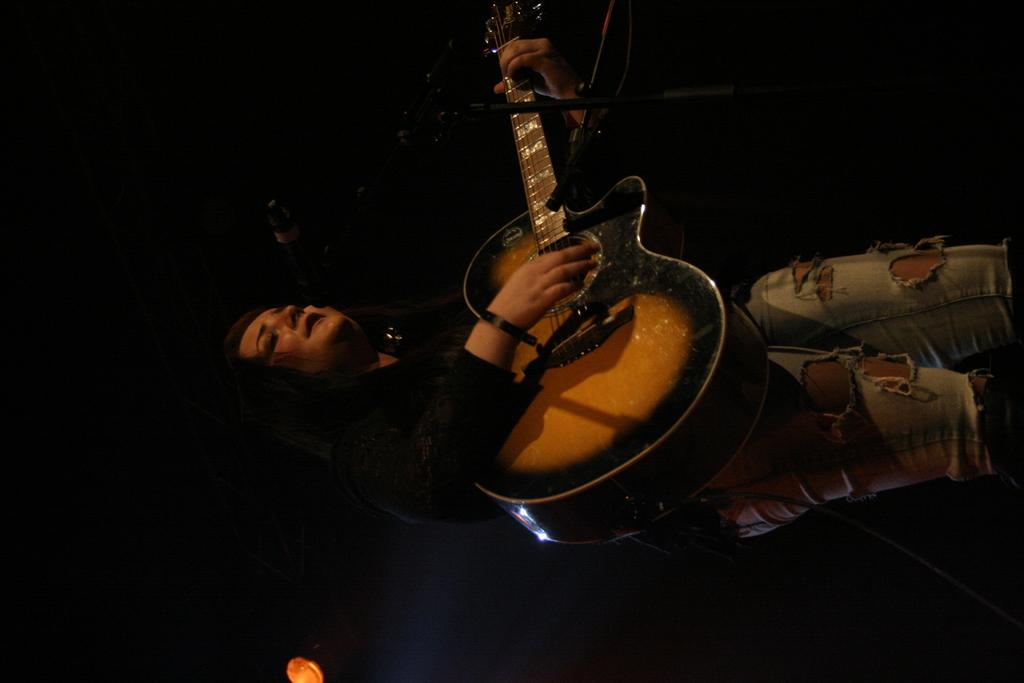Who is the main subject in the image? There is a woman in the image. What is the woman wearing? The woman is wearing a black shirt. What is the woman holding in the image? The woman is holding a guitar. What type of waste can be seen in the image? There is no waste present in the image; it features a woman wearing a black shirt and holding a guitar. 